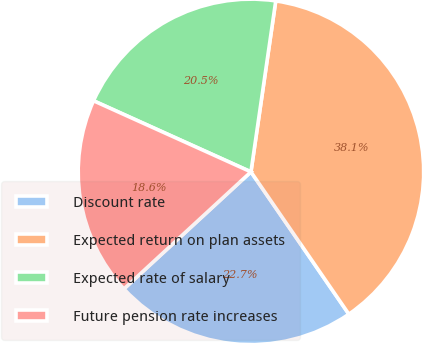<chart> <loc_0><loc_0><loc_500><loc_500><pie_chart><fcel>Discount rate<fcel>Expected return on plan assets<fcel>Expected rate of salary<fcel>Future pension rate increases<nl><fcel>22.74%<fcel>38.11%<fcel>20.54%<fcel>18.6%<nl></chart> 